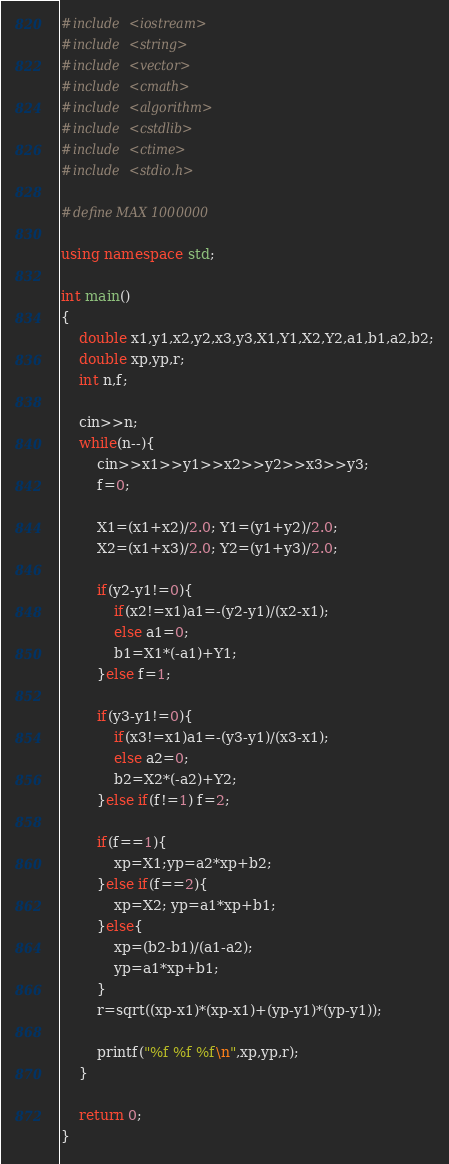<code> <loc_0><loc_0><loc_500><loc_500><_C++_>#include <iostream>
#include <string>
#include <vector>
#include <cmath>
#include <algorithm>
#include <cstdlib>
#include <ctime>
#include <stdio.h>

#define MAX 1000000

using namespace std;

int main()
{
	double x1,y1,x2,y2,x3,y3,X1,Y1,X2,Y2,a1,b1,a2,b2;
	double xp,yp,r;
	int n,f;

	cin>>n;
	while(n--){
		cin>>x1>>y1>>x2>>y2>>x3>>y3;
		f=0;

		X1=(x1+x2)/2.0; Y1=(y1+y2)/2.0;
		X2=(x1+x3)/2.0; Y2=(y1+y3)/2.0;
	
		if(y2-y1!=0){
			if(x2!=x1)a1=-(y2-y1)/(x2-x1);
			else a1=0;
			b1=X1*(-a1)+Y1;
		}else f=1;

		if(y3-y1!=0){
			if(x3!=x1)a1=-(y3-y1)/(x3-x1);
			else a2=0;
			b2=X2*(-a2)+Y2;
		}else if(f!=1) f=2;

		if(f==1){ 
			xp=X1;yp=a2*xp+b2;
		}else if(f==2){
			xp=X2; yp=a1*xp+b1;
		}else{
			xp=(b2-b1)/(a1-a2);
			yp=a1*xp+b1;
		}
		r=sqrt((xp-x1)*(xp-x1)+(yp-y1)*(yp-y1));

		printf("%f %f %f\n",xp,yp,r);
	}

	return 0;
}</code> 